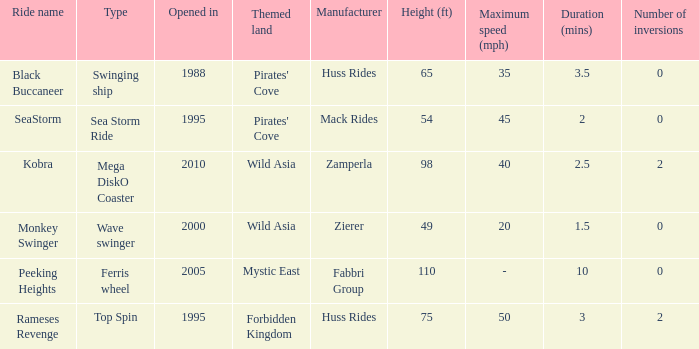Which ride opened after the 2000 Peeking Heights? Ferris wheel. 